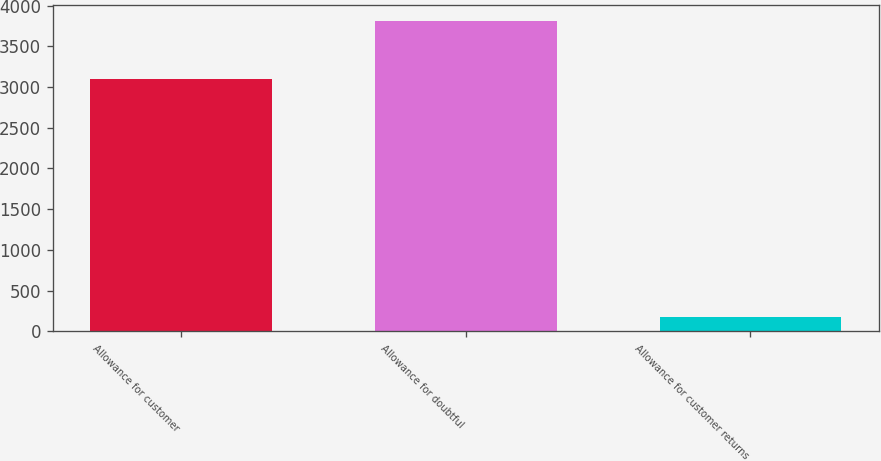Convert chart. <chart><loc_0><loc_0><loc_500><loc_500><bar_chart><fcel>Allowance for customer<fcel>Allowance for doubtful<fcel>Allowance for customer returns<nl><fcel>3094<fcel>3813<fcel>176<nl></chart> 